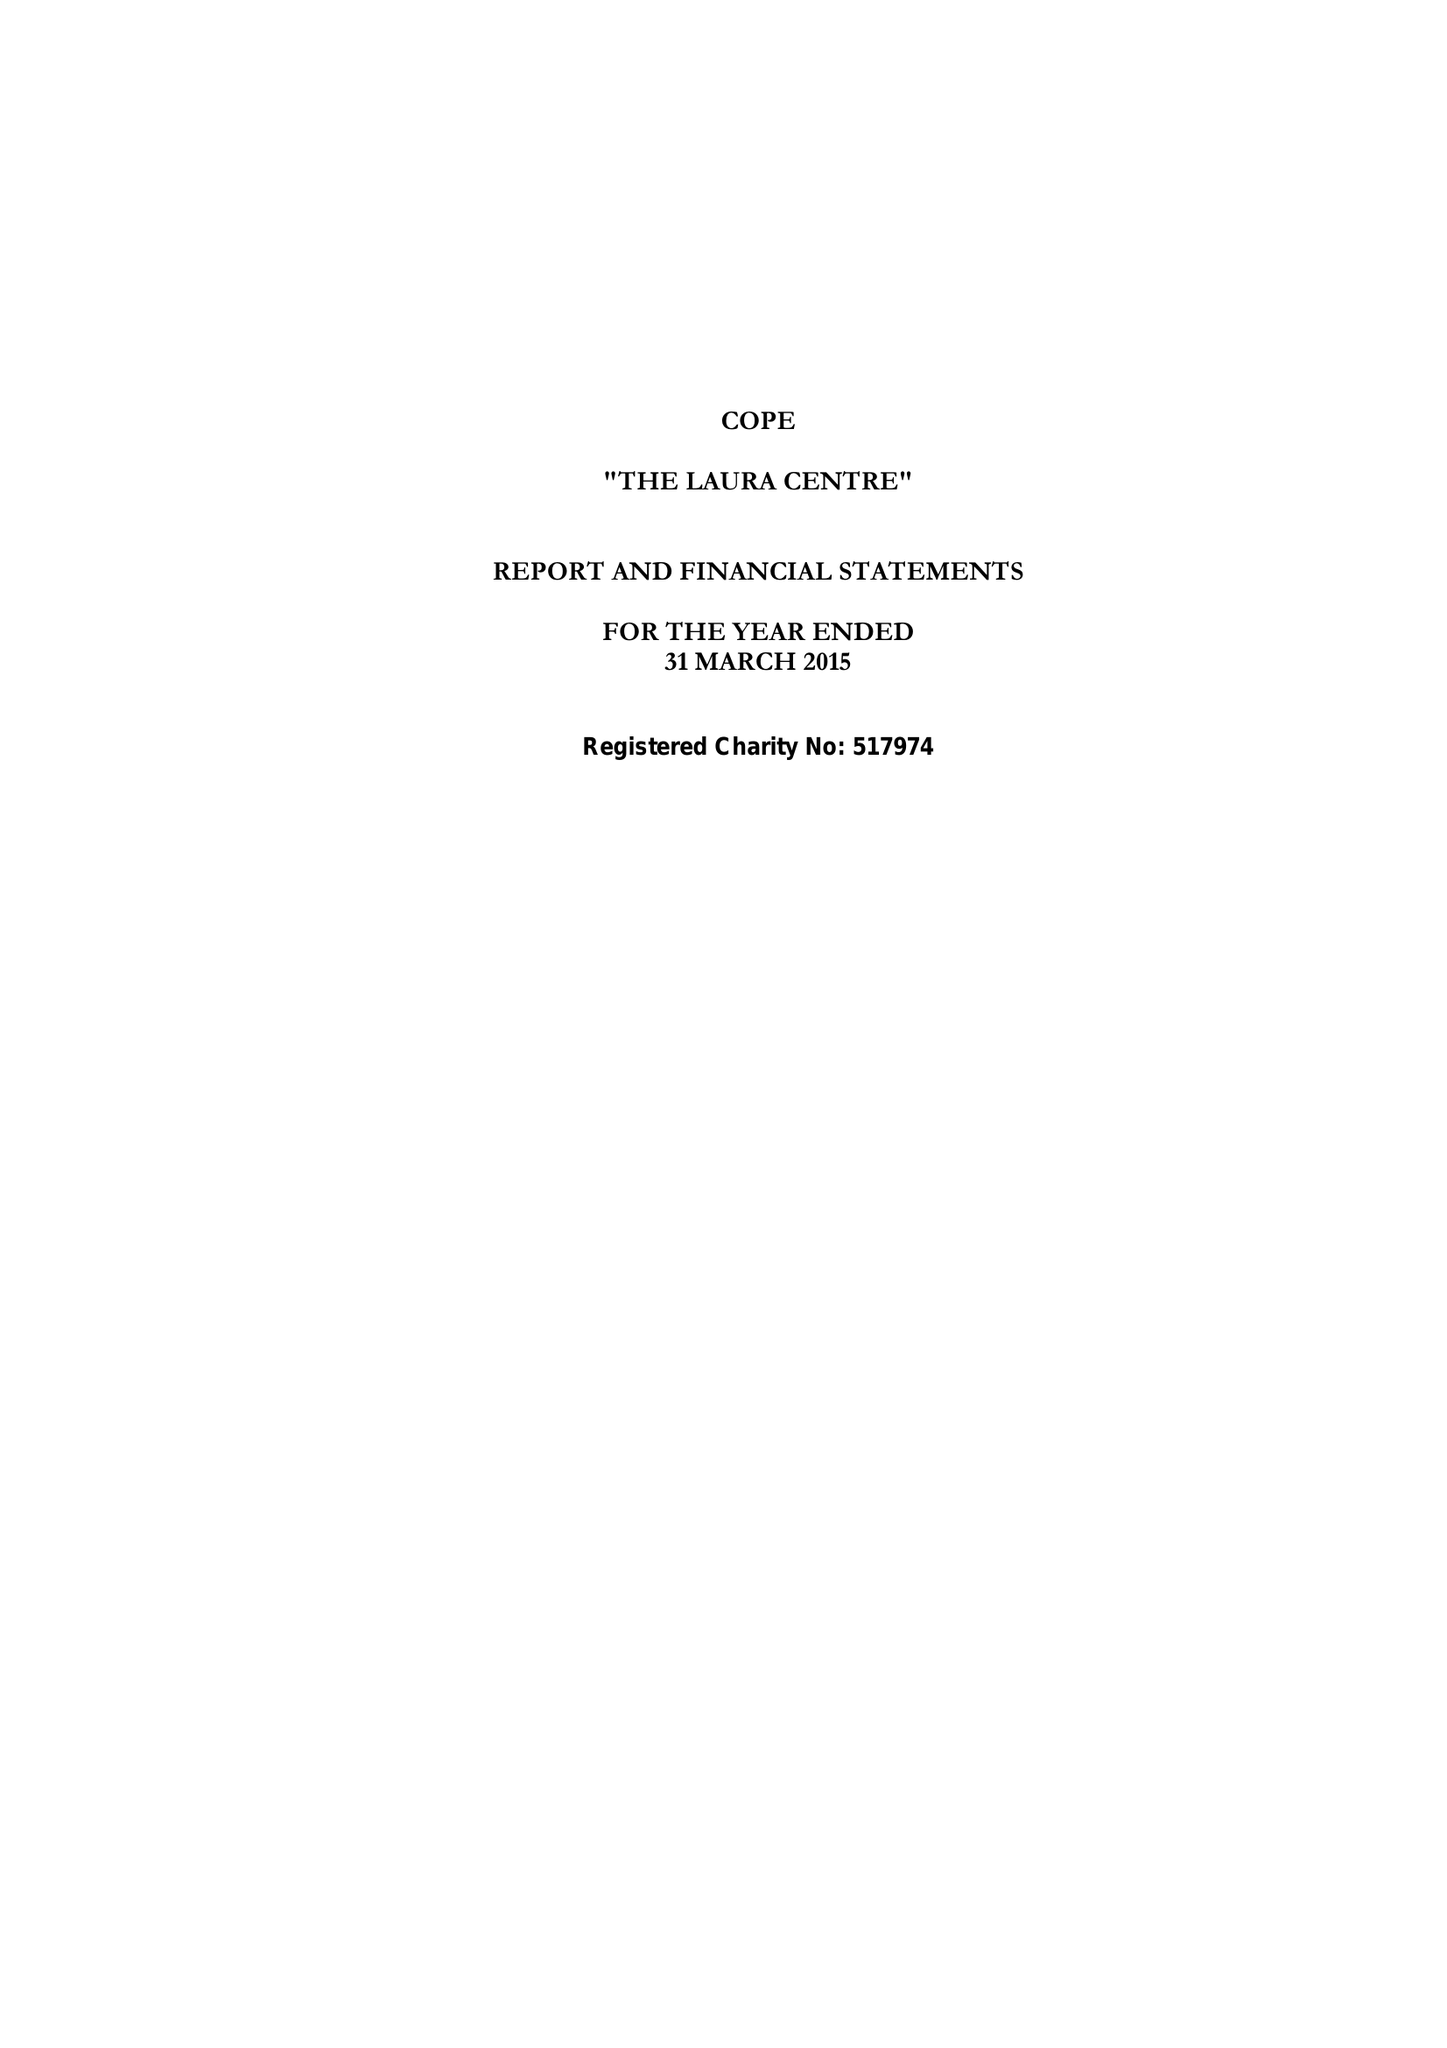What is the value for the report_date?
Answer the question using a single word or phrase. 2015-03-31 